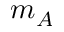<formula> <loc_0><loc_0><loc_500><loc_500>m _ { A }</formula> 